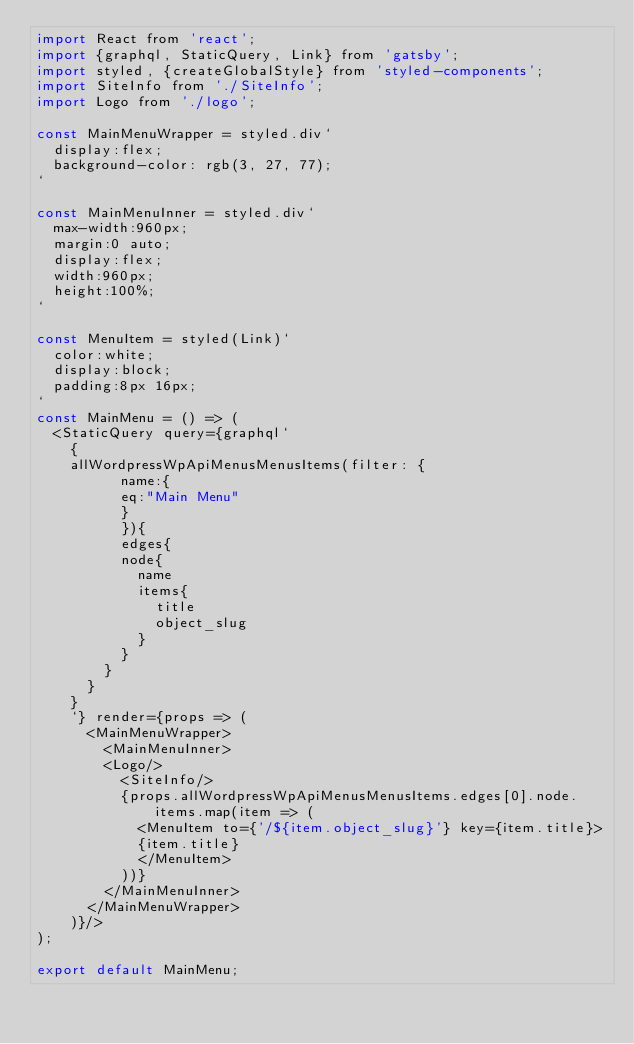<code> <loc_0><loc_0><loc_500><loc_500><_JavaScript_>import React from 'react';
import {graphql, StaticQuery, Link} from 'gatsby';
import styled, {createGlobalStyle} from 'styled-components';
import SiteInfo from './SiteInfo';
import Logo from './logo';

const MainMenuWrapper = styled.div`
  display:flex;
  background-color: rgb(3, 27, 77);
`

const MainMenuInner = styled.div`
  max-width:960px;
  margin:0 auto;
  display:flex;
  width:960px;
  height:100%;
`

const MenuItem = styled(Link)`
  color:white;
  display:block;
  padding:8px 16px;
`
const MainMenu = () => (
  <StaticQuery query={graphql`
    {
    allWordpressWpApiMenusMenusItems(filter: {
          name:{
          eq:"Main Menu"
          }
          }){
          edges{
          node{
            name
            items{
              title
              object_slug
            }
          }
        }
      }
    }
    `} render={props => (
      <MainMenuWrapper>
        <MainMenuInner>
        <Logo/>
          <SiteInfo/>
          {props.allWordpressWpApiMenusMenusItems.edges[0].node.items.map(item => (
            <MenuItem to={'/${item.object_slug}'} key={item.title}>
            {item.title}
            </MenuItem>
          ))}
        </MainMenuInner>
      </MainMenuWrapper>
    )}/>
);

export default MainMenu;
</code> 